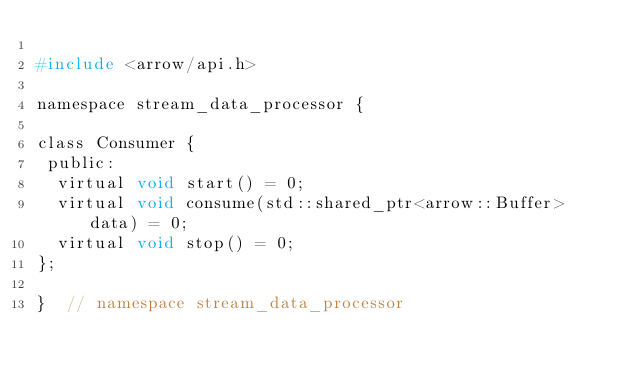Convert code to text. <code><loc_0><loc_0><loc_500><loc_500><_C_>
#include <arrow/api.h>

namespace stream_data_processor {

class Consumer {
 public:
  virtual void start() = 0;
  virtual void consume(std::shared_ptr<arrow::Buffer> data) = 0;
  virtual void stop() = 0;
};

}  // namespace stream_data_processor
</code> 